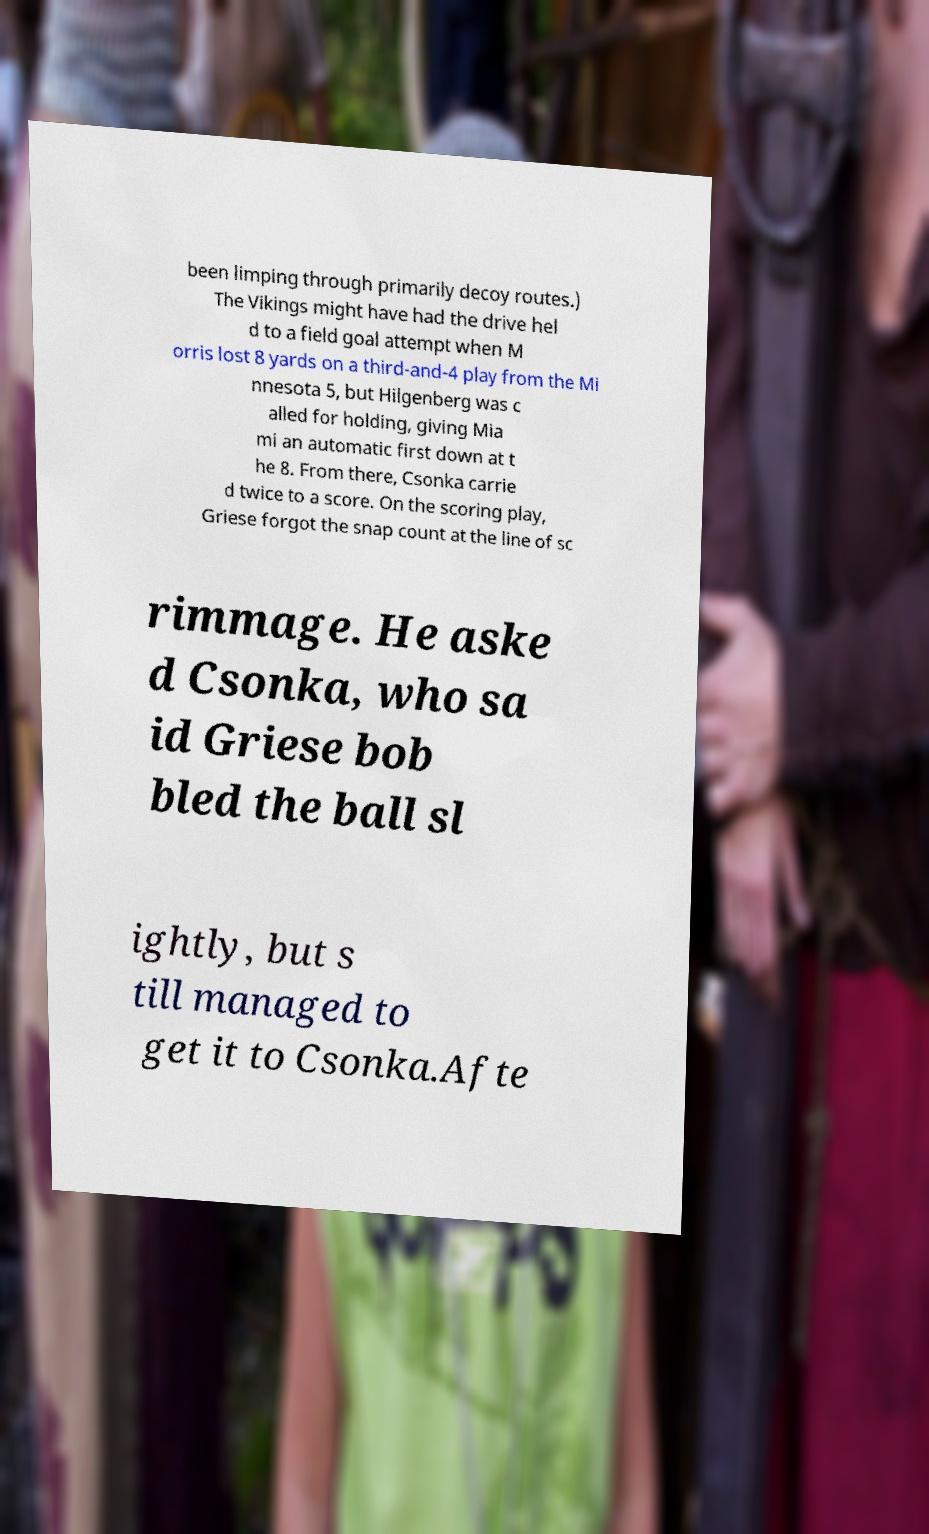Could you assist in decoding the text presented in this image and type it out clearly? been limping through primarily decoy routes.) The Vikings might have had the drive hel d to a field goal attempt when M orris lost 8 yards on a third-and-4 play from the Mi nnesota 5, but Hilgenberg was c alled for holding, giving Mia mi an automatic first down at t he 8. From there, Csonka carrie d twice to a score. On the scoring play, Griese forgot the snap count at the line of sc rimmage. He aske d Csonka, who sa id Griese bob bled the ball sl ightly, but s till managed to get it to Csonka.Afte 